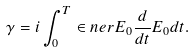<formula> <loc_0><loc_0><loc_500><loc_500>\gamma = i \int _ { 0 } ^ { T } \in n e r { E _ { 0 } } { \frac { d } { d t } E _ { 0 } } d t .</formula> 